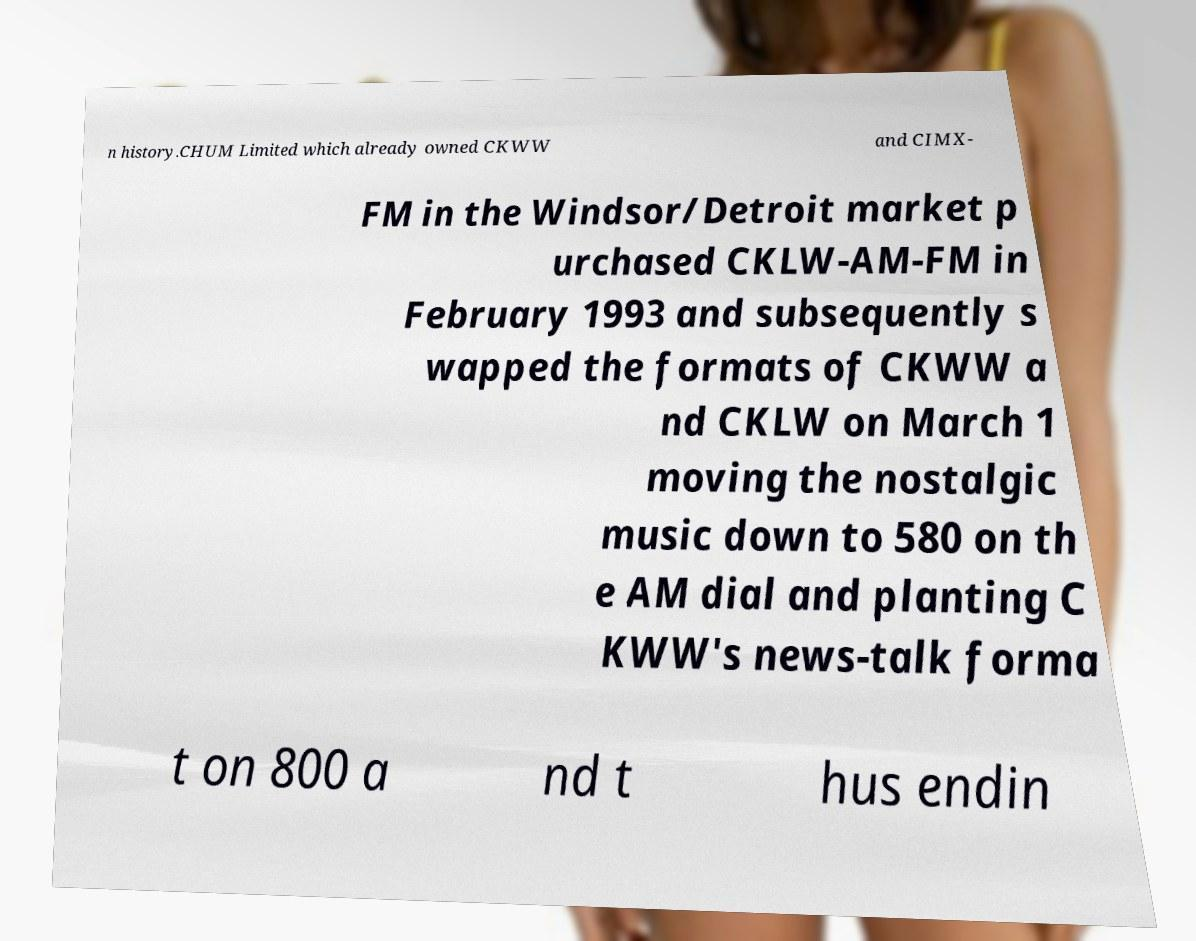There's text embedded in this image that I need extracted. Can you transcribe it verbatim? n history.CHUM Limited which already owned CKWW and CIMX- FM in the Windsor/Detroit market p urchased CKLW-AM-FM in February 1993 and subsequently s wapped the formats of CKWW a nd CKLW on March 1 moving the nostalgic music down to 580 on th e AM dial and planting C KWW's news-talk forma t on 800 a nd t hus endin 